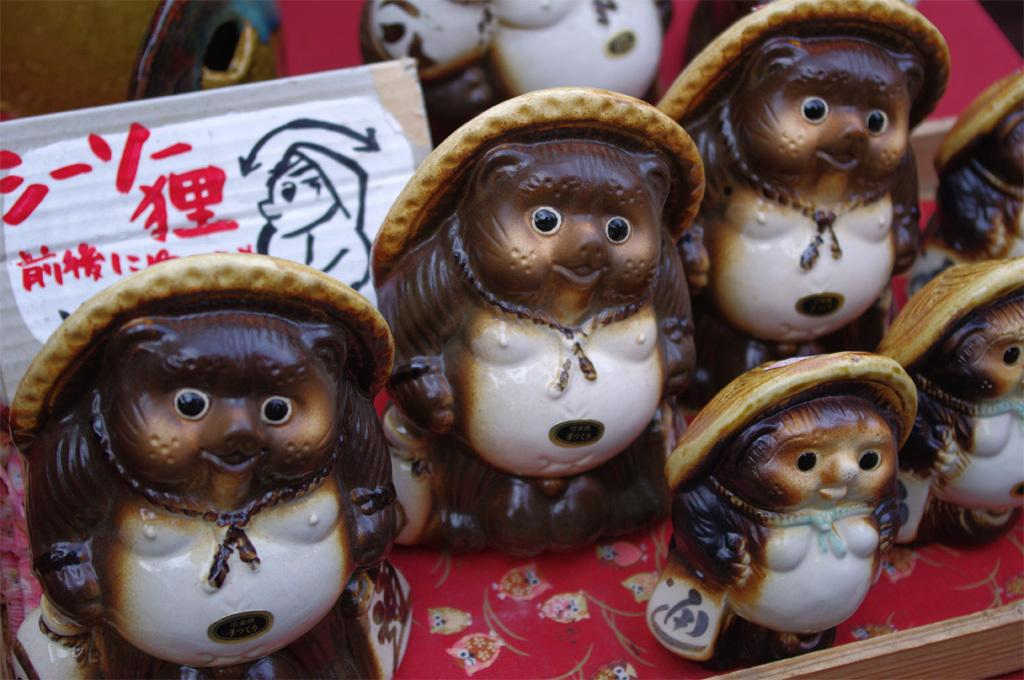What type of toys are present in the image? There are ceramic toys in the image. What type of magic can be performed with the ceramic toys in the image? There is no magic or any indication of magical abilities in the image; it simply features ceramic toys. 